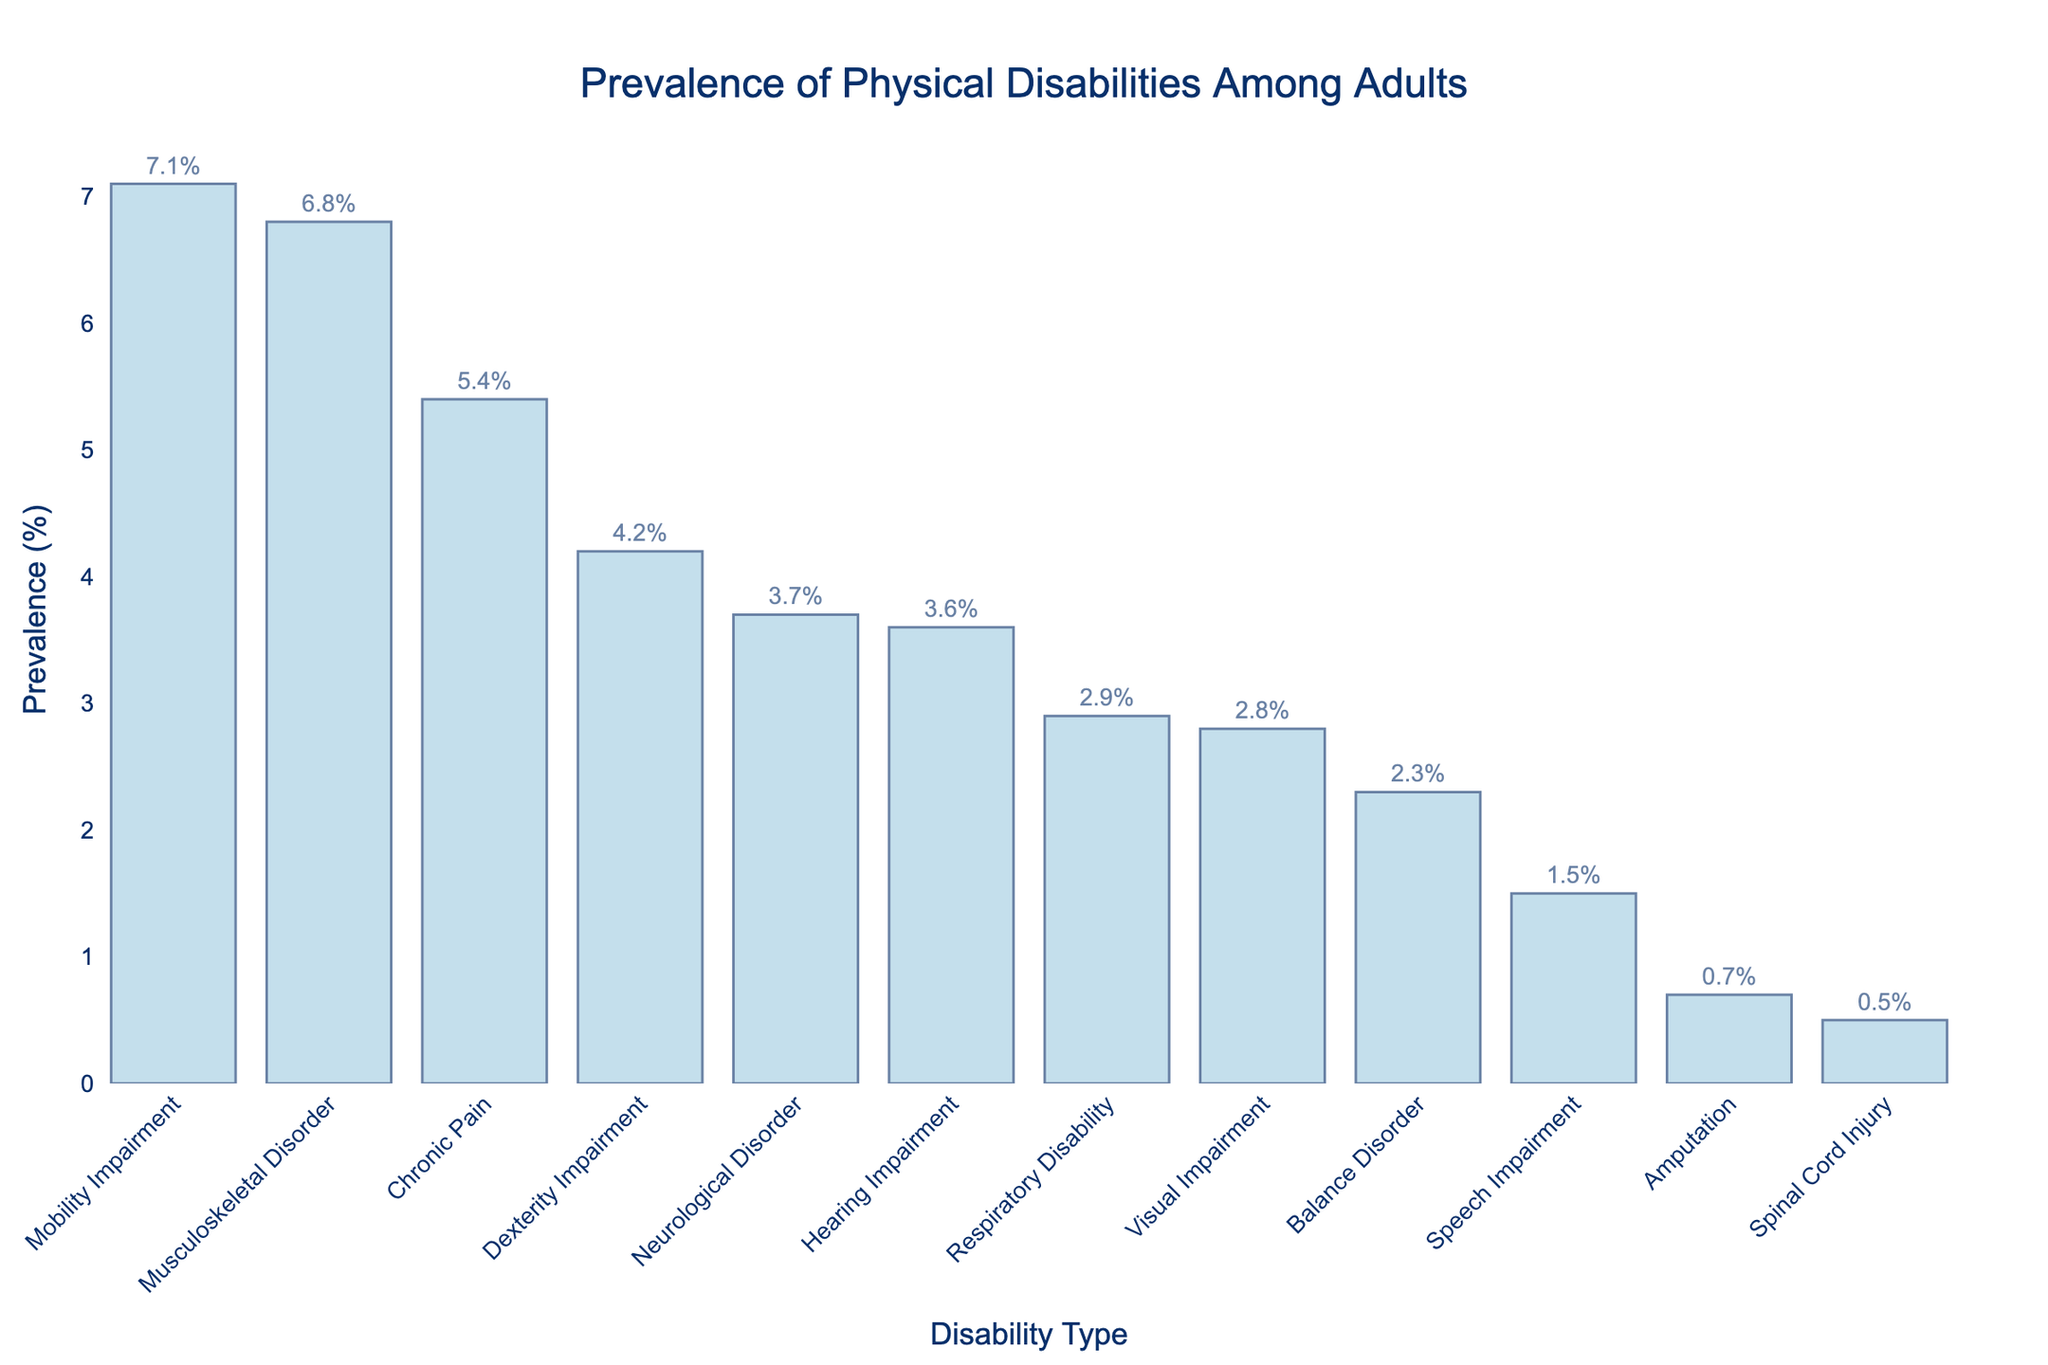Which type of physical disability has the highest prevalence among adults? By observing the height of the bars, we can see that Mobility Impairment has the tallest bar, representing the highest prevalence among the listed physical disabilities.
Answer: Mobility Impairment Which type of physical disability has the lowest prevalence among adults? The shortest bar in the chart represents the type of physical disability with the lowest prevalence, which is Spinal Cord Injury.
Answer: Spinal Cord Injury How much higher is the prevalence of Chronic Pain compared to Speech Impairment? The prevalence of Chronic Pain is 5.4%, while the prevalence of Speech Impairment is 1.5%. The difference is calculated as 5.4% - 1.5% = 3.9%.
Answer: 3.9% What is the combined prevalence of Visual Impairment and Hearing Impairment? The prevalence of Visual Impairment is 2.8%, and Hearing Impairment is 3.6%. The combined prevalence is 2.8% + 3.6% = 6.4%.
Answer: 6.4% Which has a higher prevalence: Respiratory Disability or Neurological Disorder? Comparing the height of the bars for Respiratory Disability (2.9%) and Neurological Disorder (3.7%), Neurological Disorder has a higher prevalence.
Answer: Neurological Disorder What is the average prevalence of Balance Disorder, Amputation, and Spinal Cord Injury? The prevalences are Balance Disorder (2.3%), Amputation (0.7%), and Spinal Cord Injury (0.5%). The sum is 2.3% + 0.7% + 0.5% = 3.5%. The average is 3.5% / 3 = 1.17%.
Answer: 1.17% How much higher is the prevalence of Musculoskeletal Disorder compared to Balance Disorder? The prevalence of Musculoskeletal Disorder is 6.8%, while Balance Disorder is 2.3%. The difference is 6.8% - 2.3% = 4.5%.
Answer: 4.5% Which disability type has a higher prevalence: Dexterity Impairment or Chronic Pain? By comparing the heights of the bars, Dexterity Impairment has a prevalence of 4.2%, and Chronic Pain has a prevalence of 5.4%. Chronic Pain has a higher prevalence.
Answer: Chronic Pain 